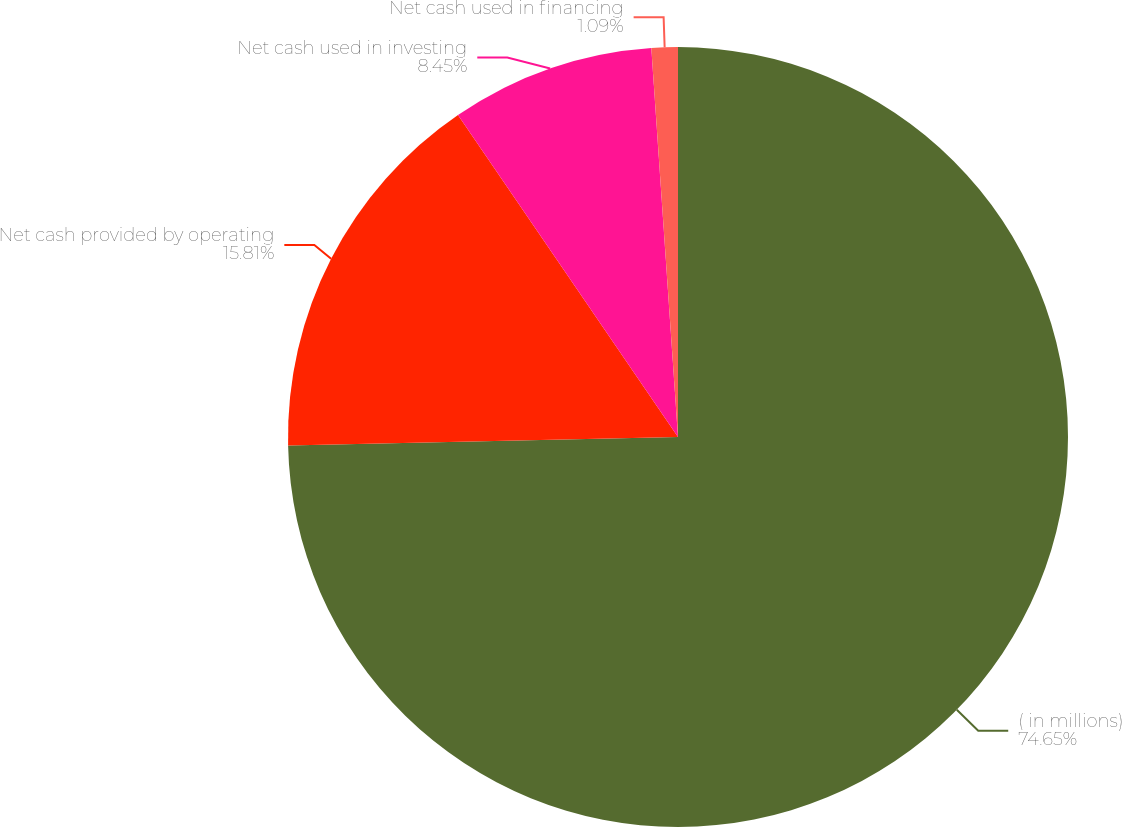<chart> <loc_0><loc_0><loc_500><loc_500><pie_chart><fcel>( in millions)<fcel>Net cash provided by operating<fcel>Net cash used in investing<fcel>Net cash used in financing<nl><fcel>74.65%<fcel>15.81%<fcel>8.45%<fcel>1.09%<nl></chart> 